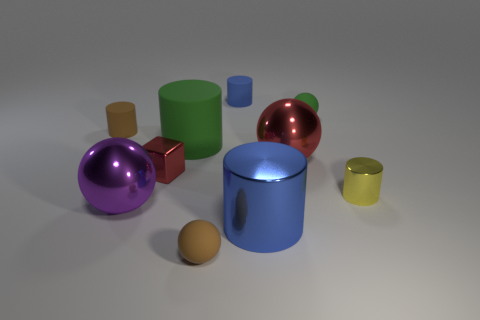Subtract all yellow metallic cylinders. How many cylinders are left? 4 Subtract all green cylinders. How many cylinders are left? 4 Subtract all red cylinders. Subtract all yellow cubes. How many cylinders are left? 5 Subtract all blocks. How many objects are left? 9 Add 7 small yellow metal cylinders. How many small yellow metal cylinders exist? 8 Subtract 0 green blocks. How many objects are left? 10 Subtract all tiny brown matte cubes. Subtract all small yellow cylinders. How many objects are left? 9 Add 1 green cylinders. How many green cylinders are left? 2 